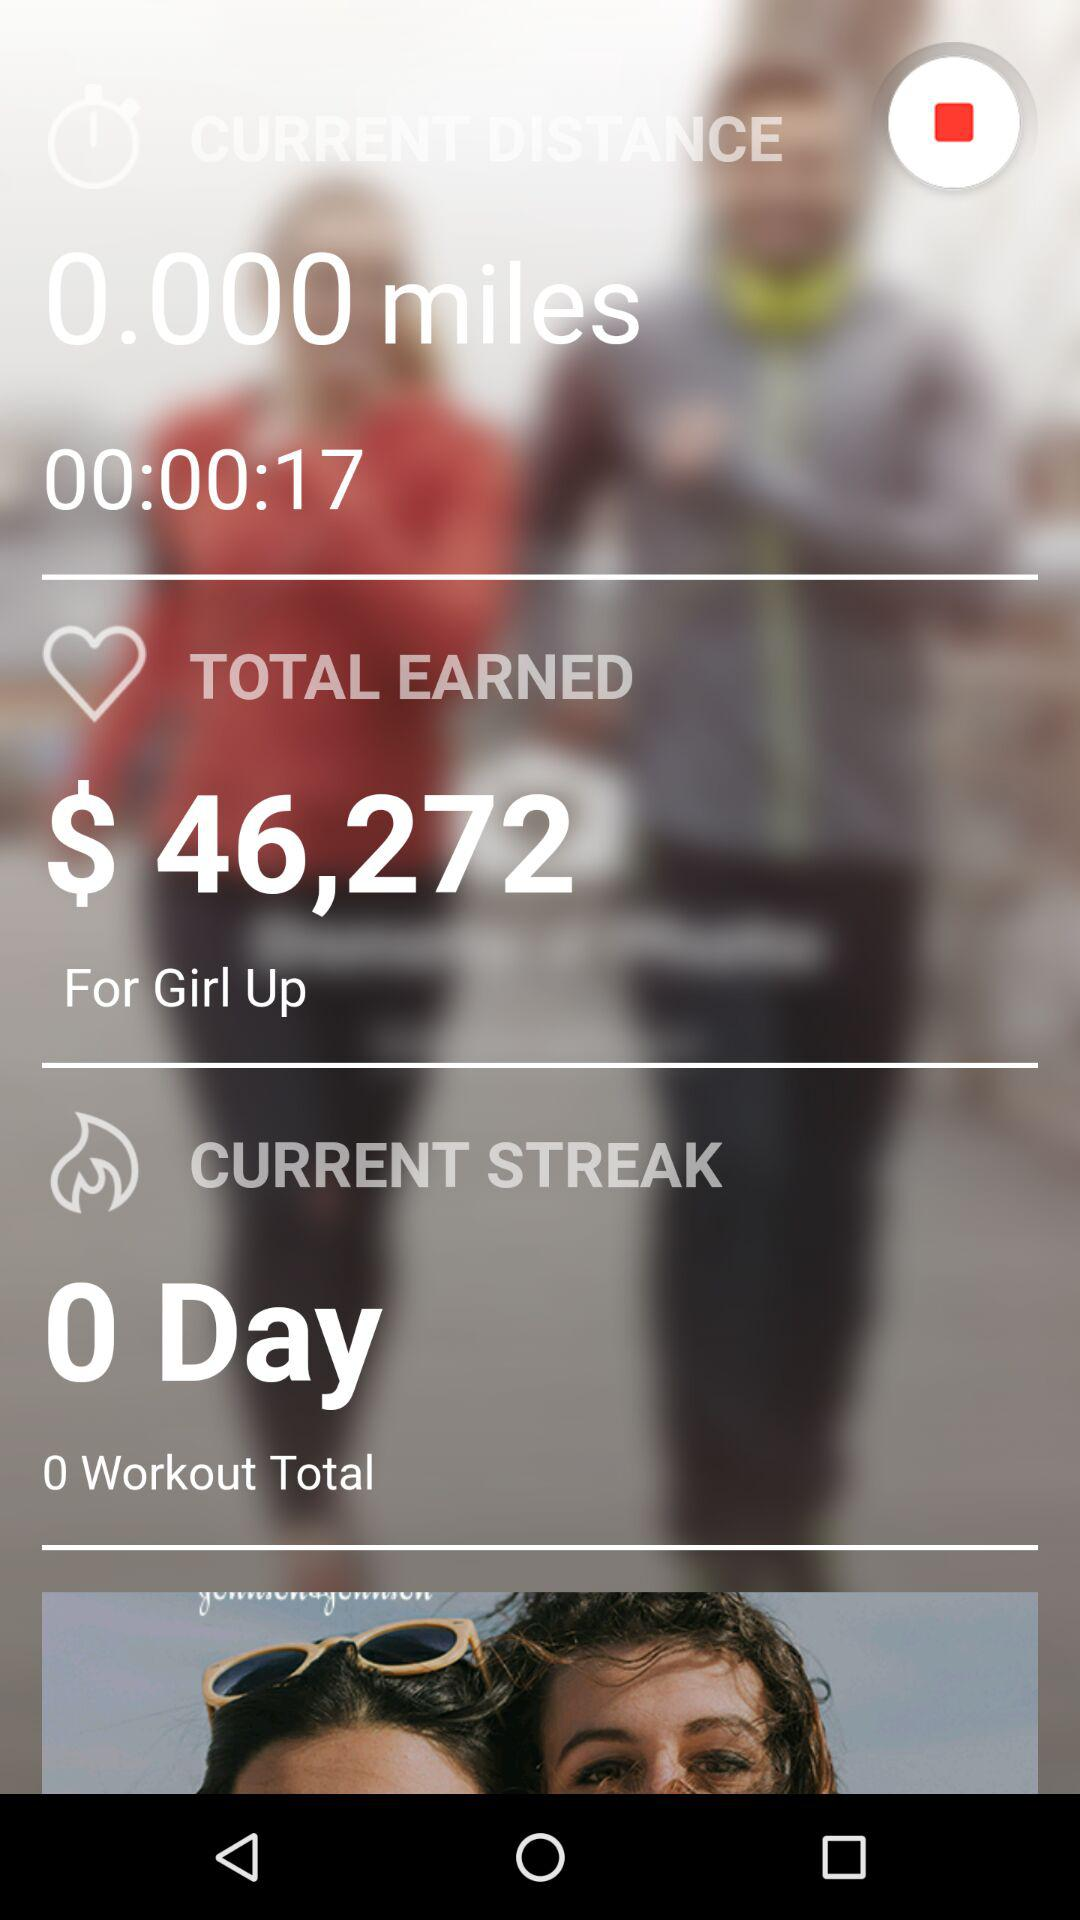What is the current streak? The current streak is 0 days. 